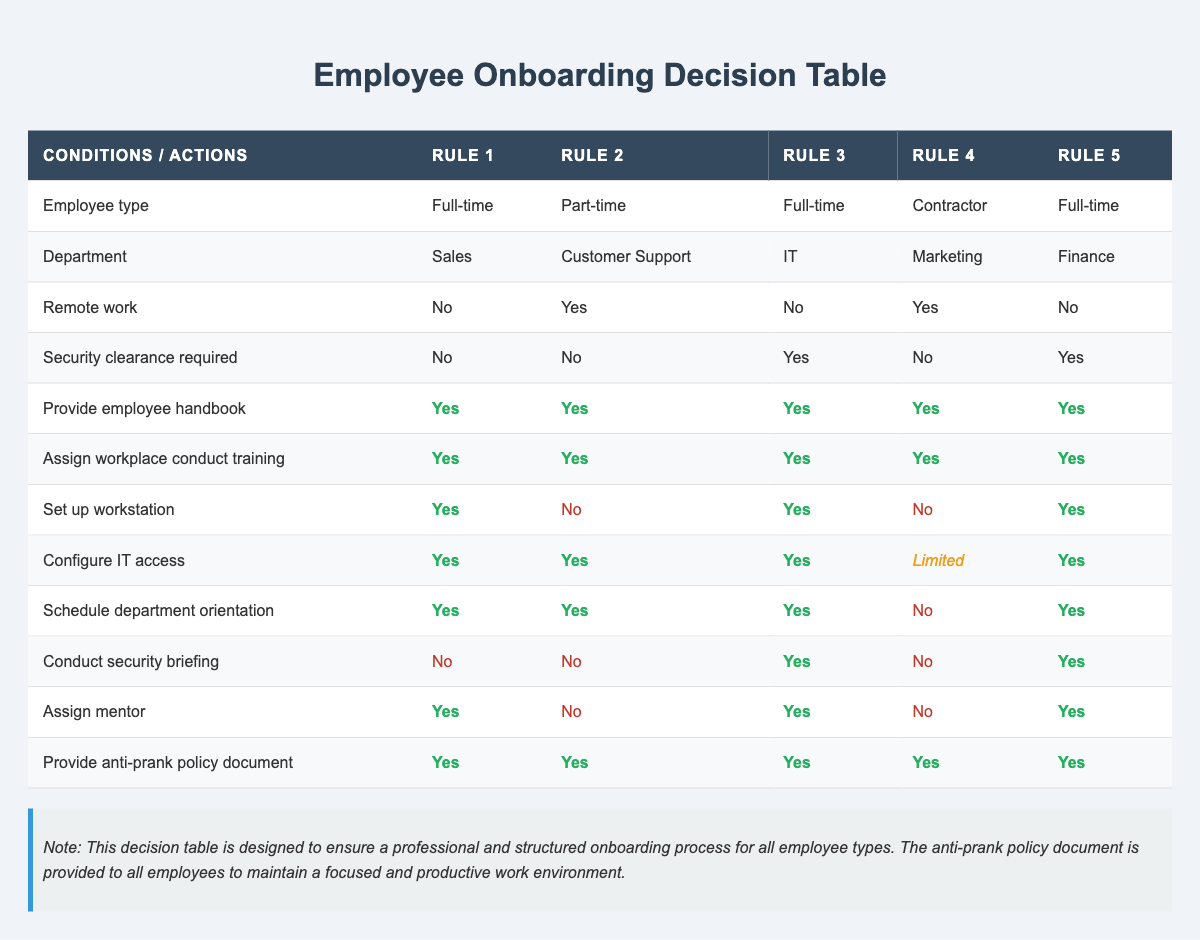What actions are required for a full-time employee in the IT department with security clearance? According to Rule 3 in the table, a full-time employee in the IT department with security clearance requires the following actions: Provide employee handbook (Yes), Assign workplace conduct training (Yes), Set up workstation (Yes), Configure IT access (Yes), Schedule department orientation (Yes), Conduct security briefing (Yes), Assign mentor (Yes), Provide anti-prank policy document (Yes).
Answer: All actions are required Do part-time employees in Customer Support who work remotely need to set up a workstation? For Rule 2, part-time employees in Customer Support who work remotely do not need to set up a workstation, as the table states "No" under "Set up workstation" for this rule.
Answer: No How many total actions are required for contractors in the Marketing department? For contractors in the Marketing department (Rule 4), there are 5 actions that are required: Provide employee handbook (Yes), Assign workplace conduct training (Yes), Configure IT access (Limited), Provide anti-prank policy document (Yes). Set up workstation (No), Schedule department orientation (No), Conduct security briefing (No), and Assign mentor (No) indicate no action. Total required actions are 4.
Answer: 4 Is an anti-prank policy document required for a full-time employee in Finance with security clearance? Referring to Rule 5, for a full-time employee in Finance with security clearance, the table indicates that an anti-prank policy document is required (Yes).
Answer: Yes For employees who work remotely, what is the most common department? Looking at the rules, only two employee types work remotely: one is in the Customer Support department (Part-time) and the other in the Marketing department (Contractor). Since there are fewer remote roles in Customer Support as compared to Marketing, thus the Marketing department is the most common for remote employees.
Answer: Marketing Which department has a requirement for security briefing? Checking through the rules, the departments with security briefing requirements are IT (Rule 3) and Finance (Rule 5). Both departments require "Conduct security briefing" (Yes).
Answer: IT and Finance Are all employee types required to complete workplace conduct training? The table indicates that all employee types, including Full-time, Part-time, and Contractor, have "Assign workplace conduct training" marked as Yes. Therefore, all employee types must complete this training.
Answer: Yes What is the only department where contractors do not receive any workstation setup? According to Rule 4 under the conditions for contractors in Marketing, they do not need to set up workstations, as indicated by "Set up workstation" (No).
Answer: Marketing How does IT access configuration differ between employee types with and without security clearances? Evaluating the rules, it shows that employees in the IT (Rule 3) and Finance (Rule 5) departments with security clearance have full IT access (Yes), while contractors in Marketing (Rule 4) have limited IT access (Limited). On the other hand, part-time employees in Customer Support (Rule 2) have full access (Yes).
Answer: IT and Finance have full access; contractors in Marketing have limited access 